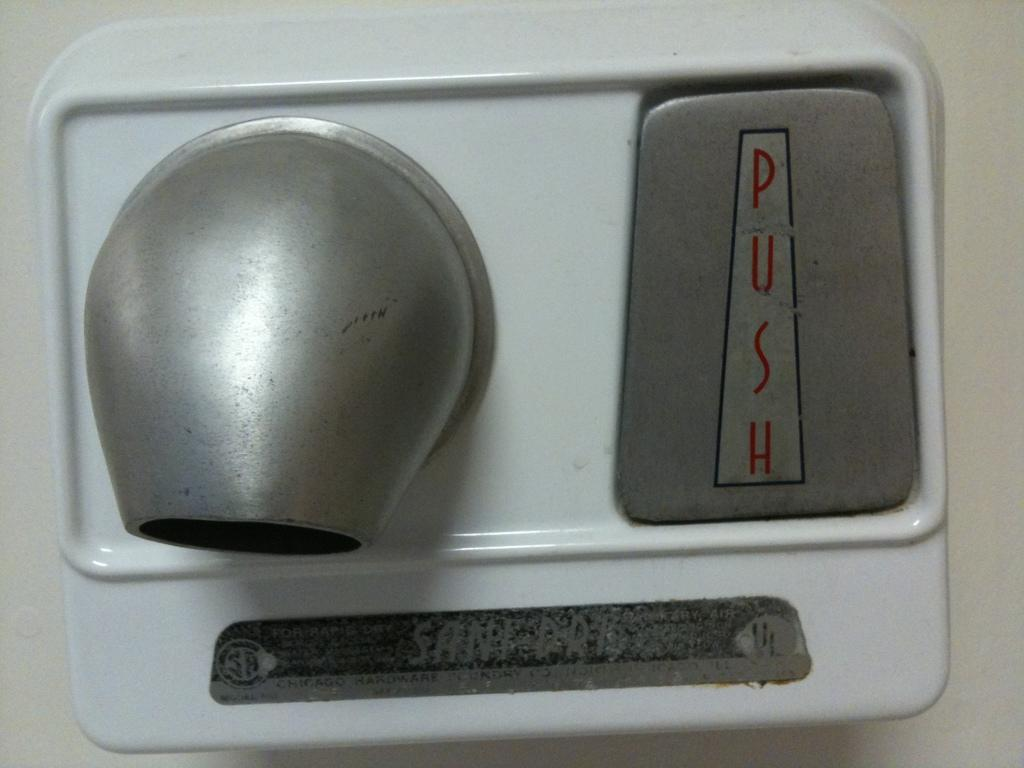<image>
Render a clear and concise summary of the photo. A hand dryer, labelled Sani Dry, has a button that says "push" on it. 